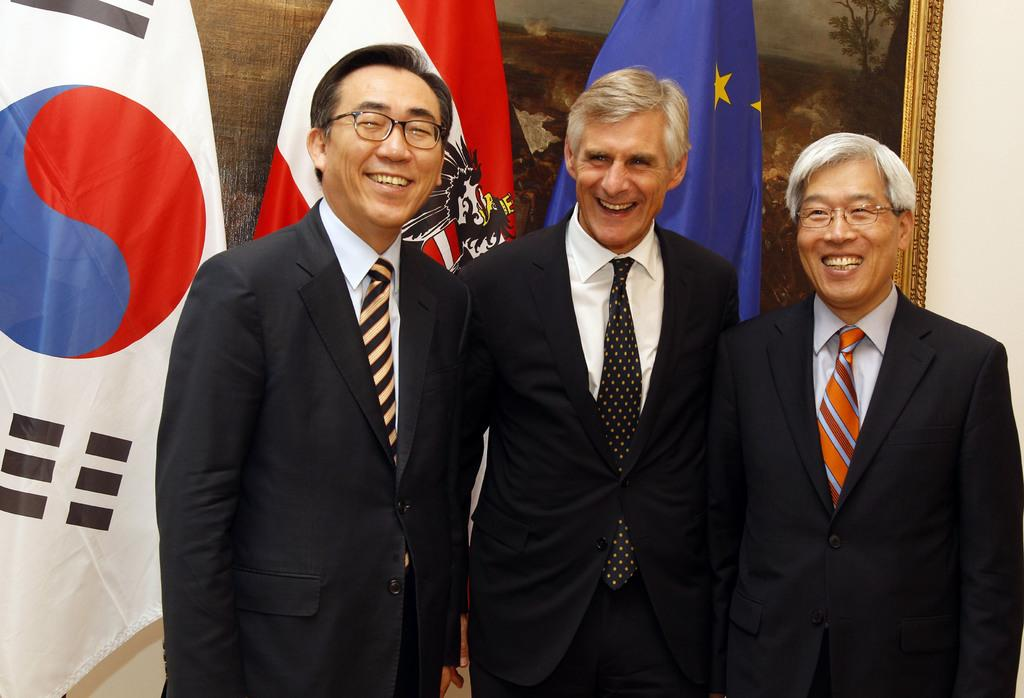How many people are present in the image? There are three persons standing in the image. What is the facial expression of the persons in the image? The persons are smiling. What accessory do two of the persons have in common? Two of the persons are wearing glasses. What can be seen in the background of the image? There are flags in the background of the image. What type of artwork is displayed on the wall in the image? There is a frame with a painting on the wall in the image. How does the painting on the wall provide comfort to the persons in the image? The painting on the wall does not provide comfort to the persons in the image, as it is an inanimate object and cannot offer comfort. 